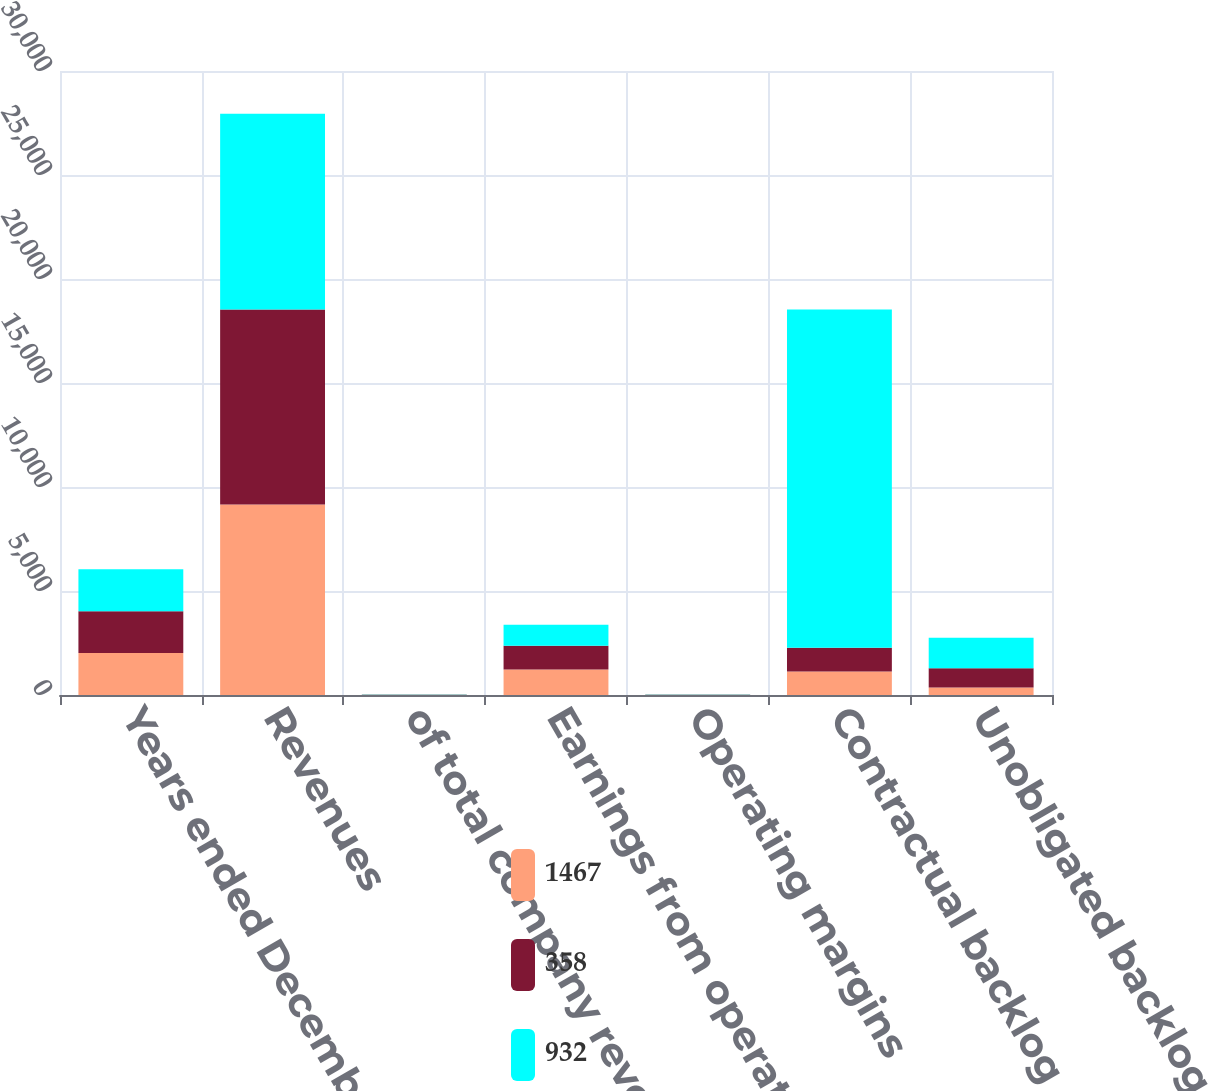Convert chart to OTSL. <chart><loc_0><loc_0><loc_500><loc_500><stacked_bar_chart><ecel><fcel>Years ended December 31<fcel>Revenues<fcel>of total company revenues<fcel>Earnings from operations<fcel>Operating margins<fcel>Contractual backlog<fcel>Unobligated backlog<nl><fcel>1467<fcel>2015<fcel>9155<fcel>10<fcel>1230<fcel>13.4<fcel>1134<fcel>358<nl><fcel>358<fcel>2014<fcel>9378<fcel>10<fcel>1134<fcel>12.1<fcel>1134<fcel>932<nl><fcel>932<fcel>2013<fcel>9410<fcel>11<fcel>1015<fcel>10.8<fcel>16269<fcel>1467<nl></chart> 